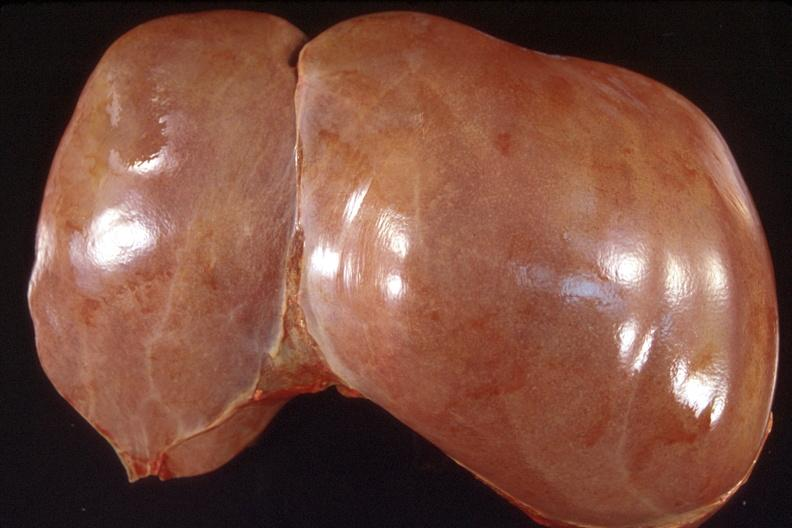what does this image show?
Answer the question using a single word or phrase. Liver 